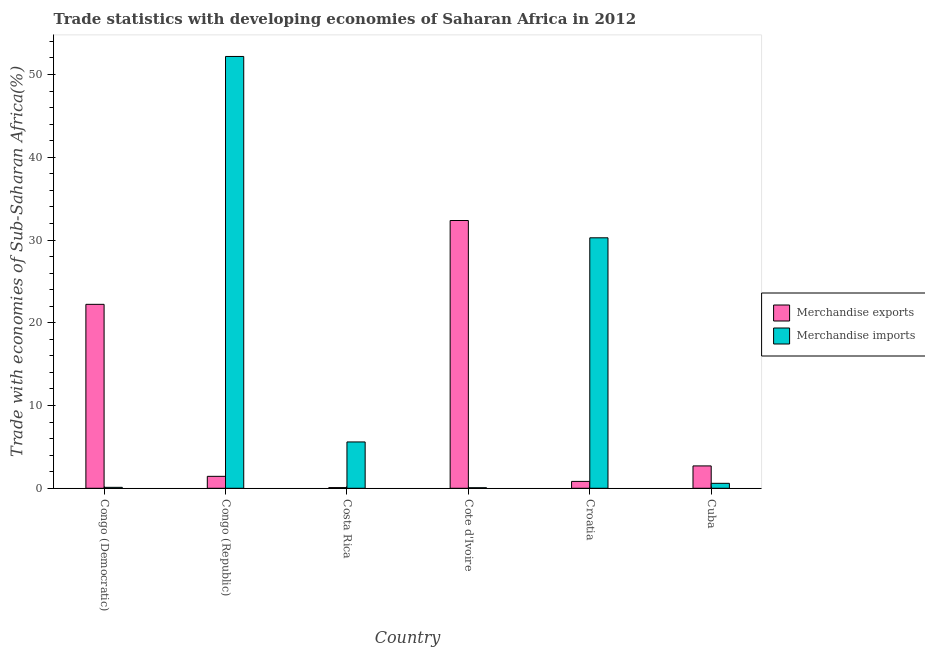How many different coloured bars are there?
Offer a very short reply. 2. How many groups of bars are there?
Keep it short and to the point. 6. How many bars are there on the 5th tick from the right?
Give a very brief answer. 2. What is the label of the 2nd group of bars from the left?
Your response must be concise. Congo (Republic). What is the merchandise imports in Congo (Republic)?
Your answer should be very brief. 52.18. Across all countries, what is the maximum merchandise exports?
Keep it short and to the point. 32.36. Across all countries, what is the minimum merchandise imports?
Give a very brief answer. 0.07. In which country was the merchandise exports maximum?
Your answer should be very brief. Cote d'Ivoire. In which country was the merchandise imports minimum?
Your response must be concise. Cote d'Ivoire. What is the total merchandise imports in the graph?
Provide a short and direct response. 88.83. What is the difference between the merchandise imports in Congo (Republic) and that in Croatia?
Your answer should be very brief. 21.92. What is the difference between the merchandise exports in Congo (Republic) and the merchandise imports in Croatia?
Your answer should be very brief. -28.83. What is the average merchandise exports per country?
Offer a terse response. 9.94. What is the difference between the merchandise exports and merchandise imports in Cote d'Ivoire?
Offer a very short reply. 32.29. In how many countries, is the merchandise imports greater than 6 %?
Offer a terse response. 2. What is the ratio of the merchandise imports in Congo (Democratic) to that in Croatia?
Your answer should be very brief. 0. Is the merchandise imports in Congo (Republic) less than that in Cuba?
Your answer should be compact. No. What is the difference between the highest and the second highest merchandise imports?
Give a very brief answer. 21.92. What is the difference between the highest and the lowest merchandise imports?
Your response must be concise. 52.12. In how many countries, is the merchandise exports greater than the average merchandise exports taken over all countries?
Provide a succinct answer. 2. Is the sum of the merchandise exports in Congo (Republic) and Cuba greater than the maximum merchandise imports across all countries?
Provide a short and direct response. No. What does the 1st bar from the left in Congo (Democratic) represents?
Keep it short and to the point. Merchandise exports. How many bars are there?
Provide a succinct answer. 12. What is the difference between two consecutive major ticks on the Y-axis?
Keep it short and to the point. 10. Does the graph contain grids?
Keep it short and to the point. No. How many legend labels are there?
Ensure brevity in your answer.  2. How are the legend labels stacked?
Offer a terse response. Vertical. What is the title of the graph?
Your answer should be very brief. Trade statistics with developing economies of Saharan Africa in 2012. What is the label or title of the Y-axis?
Provide a short and direct response. Trade with economies of Sub-Saharan Africa(%). What is the Trade with economies of Sub-Saharan Africa(%) in Merchandise exports in Congo (Democratic)?
Give a very brief answer. 22.23. What is the Trade with economies of Sub-Saharan Africa(%) in Merchandise imports in Congo (Democratic)?
Make the answer very short. 0.11. What is the Trade with economies of Sub-Saharan Africa(%) of Merchandise exports in Congo (Republic)?
Keep it short and to the point. 1.44. What is the Trade with economies of Sub-Saharan Africa(%) in Merchandise imports in Congo (Republic)?
Offer a terse response. 52.18. What is the Trade with economies of Sub-Saharan Africa(%) of Merchandise exports in Costa Rica?
Your answer should be compact. 0.08. What is the Trade with economies of Sub-Saharan Africa(%) of Merchandise imports in Costa Rica?
Provide a succinct answer. 5.6. What is the Trade with economies of Sub-Saharan Africa(%) of Merchandise exports in Cote d'Ivoire?
Make the answer very short. 32.36. What is the Trade with economies of Sub-Saharan Africa(%) in Merchandise imports in Cote d'Ivoire?
Make the answer very short. 0.07. What is the Trade with economies of Sub-Saharan Africa(%) of Merchandise exports in Croatia?
Your answer should be compact. 0.83. What is the Trade with economies of Sub-Saharan Africa(%) of Merchandise imports in Croatia?
Provide a succinct answer. 30.27. What is the Trade with economies of Sub-Saharan Africa(%) of Merchandise exports in Cuba?
Give a very brief answer. 2.7. What is the Trade with economies of Sub-Saharan Africa(%) of Merchandise imports in Cuba?
Make the answer very short. 0.6. Across all countries, what is the maximum Trade with economies of Sub-Saharan Africa(%) of Merchandise exports?
Keep it short and to the point. 32.36. Across all countries, what is the maximum Trade with economies of Sub-Saharan Africa(%) in Merchandise imports?
Make the answer very short. 52.18. Across all countries, what is the minimum Trade with economies of Sub-Saharan Africa(%) of Merchandise exports?
Your response must be concise. 0.08. Across all countries, what is the minimum Trade with economies of Sub-Saharan Africa(%) in Merchandise imports?
Your response must be concise. 0.07. What is the total Trade with economies of Sub-Saharan Africa(%) in Merchandise exports in the graph?
Make the answer very short. 59.65. What is the total Trade with economies of Sub-Saharan Africa(%) in Merchandise imports in the graph?
Provide a succinct answer. 88.83. What is the difference between the Trade with economies of Sub-Saharan Africa(%) in Merchandise exports in Congo (Democratic) and that in Congo (Republic)?
Your answer should be compact. 20.79. What is the difference between the Trade with economies of Sub-Saharan Africa(%) of Merchandise imports in Congo (Democratic) and that in Congo (Republic)?
Make the answer very short. -52.07. What is the difference between the Trade with economies of Sub-Saharan Africa(%) of Merchandise exports in Congo (Democratic) and that in Costa Rica?
Keep it short and to the point. 22.15. What is the difference between the Trade with economies of Sub-Saharan Africa(%) in Merchandise imports in Congo (Democratic) and that in Costa Rica?
Provide a succinct answer. -5.48. What is the difference between the Trade with economies of Sub-Saharan Africa(%) in Merchandise exports in Congo (Democratic) and that in Cote d'Ivoire?
Give a very brief answer. -10.13. What is the difference between the Trade with economies of Sub-Saharan Africa(%) of Merchandise imports in Congo (Democratic) and that in Cote d'Ivoire?
Your answer should be compact. 0.05. What is the difference between the Trade with economies of Sub-Saharan Africa(%) in Merchandise exports in Congo (Democratic) and that in Croatia?
Give a very brief answer. 21.4. What is the difference between the Trade with economies of Sub-Saharan Africa(%) in Merchandise imports in Congo (Democratic) and that in Croatia?
Your answer should be very brief. -30.15. What is the difference between the Trade with economies of Sub-Saharan Africa(%) of Merchandise exports in Congo (Democratic) and that in Cuba?
Your answer should be very brief. 19.53. What is the difference between the Trade with economies of Sub-Saharan Africa(%) of Merchandise imports in Congo (Democratic) and that in Cuba?
Ensure brevity in your answer.  -0.49. What is the difference between the Trade with economies of Sub-Saharan Africa(%) of Merchandise exports in Congo (Republic) and that in Costa Rica?
Provide a succinct answer. 1.36. What is the difference between the Trade with economies of Sub-Saharan Africa(%) in Merchandise imports in Congo (Republic) and that in Costa Rica?
Give a very brief answer. 46.59. What is the difference between the Trade with economies of Sub-Saharan Africa(%) of Merchandise exports in Congo (Republic) and that in Cote d'Ivoire?
Ensure brevity in your answer.  -30.92. What is the difference between the Trade with economies of Sub-Saharan Africa(%) in Merchandise imports in Congo (Republic) and that in Cote d'Ivoire?
Offer a very short reply. 52.12. What is the difference between the Trade with economies of Sub-Saharan Africa(%) of Merchandise exports in Congo (Republic) and that in Croatia?
Provide a succinct answer. 0.61. What is the difference between the Trade with economies of Sub-Saharan Africa(%) of Merchandise imports in Congo (Republic) and that in Croatia?
Provide a succinct answer. 21.92. What is the difference between the Trade with economies of Sub-Saharan Africa(%) in Merchandise exports in Congo (Republic) and that in Cuba?
Provide a succinct answer. -1.26. What is the difference between the Trade with economies of Sub-Saharan Africa(%) in Merchandise imports in Congo (Republic) and that in Cuba?
Make the answer very short. 51.58. What is the difference between the Trade with economies of Sub-Saharan Africa(%) of Merchandise exports in Costa Rica and that in Cote d'Ivoire?
Your answer should be very brief. -32.28. What is the difference between the Trade with economies of Sub-Saharan Africa(%) of Merchandise imports in Costa Rica and that in Cote d'Ivoire?
Make the answer very short. 5.53. What is the difference between the Trade with economies of Sub-Saharan Africa(%) of Merchandise exports in Costa Rica and that in Croatia?
Your answer should be very brief. -0.75. What is the difference between the Trade with economies of Sub-Saharan Africa(%) of Merchandise imports in Costa Rica and that in Croatia?
Give a very brief answer. -24.67. What is the difference between the Trade with economies of Sub-Saharan Africa(%) of Merchandise exports in Costa Rica and that in Cuba?
Your answer should be very brief. -2.62. What is the difference between the Trade with economies of Sub-Saharan Africa(%) in Merchandise imports in Costa Rica and that in Cuba?
Offer a very short reply. 5. What is the difference between the Trade with economies of Sub-Saharan Africa(%) of Merchandise exports in Cote d'Ivoire and that in Croatia?
Keep it short and to the point. 31.53. What is the difference between the Trade with economies of Sub-Saharan Africa(%) in Merchandise imports in Cote d'Ivoire and that in Croatia?
Provide a succinct answer. -30.2. What is the difference between the Trade with economies of Sub-Saharan Africa(%) in Merchandise exports in Cote d'Ivoire and that in Cuba?
Keep it short and to the point. 29.66. What is the difference between the Trade with economies of Sub-Saharan Africa(%) in Merchandise imports in Cote d'Ivoire and that in Cuba?
Your answer should be compact. -0.53. What is the difference between the Trade with economies of Sub-Saharan Africa(%) of Merchandise exports in Croatia and that in Cuba?
Give a very brief answer. -1.87. What is the difference between the Trade with economies of Sub-Saharan Africa(%) in Merchandise imports in Croatia and that in Cuba?
Your answer should be very brief. 29.67. What is the difference between the Trade with economies of Sub-Saharan Africa(%) in Merchandise exports in Congo (Democratic) and the Trade with economies of Sub-Saharan Africa(%) in Merchandise imports in Congo (Republic)?
Offer a very short reply. -29.96. What is the difference between the Trade with economies of Sub-Saharan Africa(%) in Merchandise exports in Congo (Democratic) and the Trade with economies of Sub-Saharan Africa(%) in Merchandise imports in Costa Rica?
Make the answer very short. 16.63. What is the difference between the Trade with economies of Sub-Saharan Africa(%) of Merchandise exports in Congo (Democratic) and the Trade with economies of Sub-Saharan Africa(%) of Merchandise imports in Cote d'Ivoire?
Provide a short and direct response. 22.16. What is the difference between the Trade with economies of Sub-Saharan Africa(%) in Merchandise exports in Congo (Democratic) and the Trade with economies of Sub-Saharan Africa(%) in Merchandise imports in Croatia?
Provide a short and direct response. -8.04. What is the difference between the Trade with economies of Sub-Saharan Africa(%) in Merchandise exports in Congo (Democratic) and the Trade with economies of Sub-Saharan Africa(%) in Merchandise imports in Cuba?
Offer a very short reply. 21.63. What is the difference between the Trade with economies of Sub-Saharan Africa(%) of Merchandise exports in Congo (Republic) and the Trade with economies of Sub-Saharan Africa(%) of Merchandise imports in Costa Rica?
Your answer should be compact. -4.16. What is the difference between the Trade with economies of Sub-Saharan Africa(%) in Merchandise exports in Congo (Republic) and the Trade with economies of Sub-Saharan Africa(%) in Merchandise imports in Cote d'Ivoire?
Provide a short and direct response. 1.38. What is the difference between the Trade with economies of Sub-Saharan Africa(%) of Merchandise exports in Congo (Republic) and the Trade with economies of Sub-Saharan Africa(%) of Merchandise imports in Croatia?
Your answer should be compact. -28.83. What is the difference between the Trade with economies of Sub-Saharan Africa(%) of Merchandise exports in Congo (Republic) and the Trade with economies of Sub-Saharan Africa(%) of Merchandise imports in Cuba?
Give a very brief answer. 0.84. What is the difference between the Trade with economies of Sub-Saharan Africa(%) of Merchandise exports in Costa Rica and the Trade with economies of Sub-Saharan Africa(%) of Merchandise imports in Cote d'Ivoire?
Ensure brevity in your answer.  0.01. What is the difference between the Trade with economies of Sub-Saharan Africa(%) of Merchandise exports in Costa Rica and the Trade with economies of Sub-Saharan Africa(%) of Merchandise imports in Croatia?
Provide a short and direct response. -30.19. What is the difference between the Trade with economies of Sub-Saharan Africa(%) in Merchandise exports in Costa Rica and the Trade with economies of Sub-Saharan Africa(%) in Merchandise imports in Cuba?
Provide a succinct answer. -0.52. What is the difference between the Trade with economies of Sub-Saharan Africa(%) in Merchandise exports in Cote d'Ivoire and the Trade with economies of Sub-Saharan Africa(%) in Merchandise imports in Croatia?
Your answer should be very brief. 2.09. What is the difference between the Trade with economies of Sub-Saharan Africa(%) of Merchandise exports in Cote d'Ivoire and the Trade with economies of Sub-Saharan Africa(%) of Merchandise imports in Cuba?
Give a very brief answer. 31.76. What is the difference between the Trade with economies of Sub-Saharan Africa(%) in Merchandise exports in Croatia and the Trade with economies of Sub-Saharan Africa(%) in Merchandise imports in Cuba?
Your response must be concise. 0.23. What is the average Trade with economies of Sub-Saharan Africa(%) of Merchandise exports per country?
Your answer should be very brief. 9.94. What is the average Trade with economies of Sub-Saharan Africa(%) of Merchandise imports per country?
Your answer should be very brief. 14.81. What is the difference between the Trade with economies of Sub-Saharan Africa(%) of Merchandise exports and Trade with economies of Sub-Saharan Africa(%) of Merchandise imports in Congo (Democratic)?
Your answer should be very brief. 22.11. What is the difference between the Trade with economies of Sub-Saharan Africa(%) of Merchandise exports and Trade with economies of Sub-Saharan Africa(%) of Merchandise imports in Congo (Republic)?
Provide a succinct answer. -50.74. What is the difference between the Trade with economies of Sub-Saharan Africa(%) of Merchandise exports and Trade with economies of Sub-Saharan Africa(%) of Merchandise imports in Costa Rica?
Make the answer very short. -5.52. What is the difference between the Trade with economies of Sub-Saharan Africa(%) in Merchandise exports and Trade with economies of Sub-Saharan Africa(%) in Merchandise imports in Cote d'Ivoire?
Make the answer very short. 32.29. What is the difference between the Trade with economies of Sub-Saharan Africa(%) of Merchandise exports and Trade with economies of Sub-Saharan Africa(%) of Merchandise imports in Croatia?
Provide a short and direct response. -29.44. What is the difference between the Trade with economies of Sub-Saharan Africa(%) of Merchandise exports and Trade with economies of Sub-Saharan Africa(%) of Merchandise imports in Cuba?
Your response must be concise. 2.1. What is the ratio of the Trade with economies of Sub-Saharan Africa(%) in Merchandise exports in Congo (Democratic) to that in Congo (Republic)?
Ensure brevity in your answer.  15.41. What is the ratio of the Trade with economies of Sub-Saharan Africa(%) of Merchandise imports in Congo (Democratic) to that in Congo (Republic)?
Offer a terse response. 0. What is the ratio of the Trade with economies of Sub-Saharan Africa(%) of Merchandise exports in Congo (Democratic) to that in Costa Rica?
Your answer should be very brief. 272.41. What is the ratio of the Trade with economies of Sub-Saharan Africa(%) in Merchandise imports in Congo (Democratic) to that in Costa Rica?
Make the answer very short. 0.02. What is the ratio of the Trade with economies of Sub-Saharan Africa(%) of Merchandise exports in Congo (Democratic) to that in Cote d'Ivoire?
Your answer should be very brief. 0.69. What is the ratio of the Trade with economies of Sub-Saharan Africa(%) of Merchandise imports in Congo (Democratic) to that in Cote d'Ivoire?
Your response must be concise. 1.7. What is the ratio of the Trade with economies of Sub-Saharan Africa(%) in Merchandise exports in Congo (Democratic) to that in Croatia?
Ensure brevity in your answer.  26.71. What is the ratio of the Trade with economies of Sub-Saharan Africa(%) of Merchandise imports in Congo (Democratic) to that in Croatia?
Provide a succinct answer. 0. What is the ratio of the Trade with economies of Sub-Saharan Africa(%) in Merchandise exports in Congo (Democratic) to that in Cuba?
Your answer should be compact. 8.23. What is the ratio of the Trade with economies of Sub-Saharan Africa(%) of Merchandise imports in Congo (Democratic) to that in Cuba?
Your answer should be very brief. 0.19. What is the ratio of the Trade with economies of Sub-Saharan Africa(%) in Merchandise exports in Congo (Republic) to that in Costa Rica?
Your response must be concise. 17.68. What is the ratio of the Trade with economies of Sub-Saharan Africa(%) in Merchandise imports in Congo (Republic) to that in Costa Rica?
Keep it short and to the point. 9.32. What is the ratio of the Trade with economies of Sub-Saharan Africa(%) of Merchandise exports in Congo (Republic) to that in Cote d'Ivoire?
Offer a very short reply. 0.04. What is the ratio of the Trade with economies of Sub-Saharan Africa(%) in Merchandise imports in Congo (Republic) to that in Cote d'Ivoire?
Ensure brevity in your answer.  774.17. What is the ratio of the Trade with economies of Sub-Saharan Africa(%) of Merchandise exports in Congo (Republic) to that in Croatia?
Offer a very short reply. 1.73. What is the ratio of the Trade with economies of Sub-Saharan Africa(%) of Merchandise imports in Congo (Republic) to that in Croatia?
Make the answer very short. 1.72. What is the ratio of the Trade with economies of Sub-Saharan Africa(%) in Merchandise exports in Congo (Republic) to that in Cuba?
Keep it short and to the point. 0.53. What is the ratio of the Trade with economies of Sub-Saharan Africa(%) in Merchandise imports in Congo (Republic) to that in Cuba?
Give a very brief answer. 86.96. What is the ratio of the Trade with economies of Sub-Saharan Africa(%) of Merchandise exports in Costa Rica to that in Cote d'Ivoire?
Make the answer very short. 0. What is the ratio of the Trade with economies of Sub-Saharan Africa(%) of Merchandise imports in Costa Rica to that in Cote d'Ivoire?
Offer a very short reply. 83.06. What is the ratio of the Trade with economies of Sub-Saharan Africa(%) of Merchandise exports in Costa Rica to that in Croatia?
Keep it short and to the point. 0.1. What is the ratio of the Trade with economies of Sub-Saharan Africa(%) of Merchandise imports in Costa Rica to that in Croatia?
Ensure brevity in your answer.  0.18. What is the ratio of the Trade with economies of Sub-Saharan Africa(%) in Merchandise exports in Costa Rica to that in Cuba?
Provide a short and direct response. 0.03. What is the ratio of the Trade with economies of Sub-Saharan Africa(%) of Merchandise imports in Costa Rica to that in Cuba?
Give a very brief answer. 9.33. What is the ratio of the Trade with economies of Sub-Saharan Africa(%) in Merchandise exports in Cote d'Ivoire to that in Croatia?
Your answer should be very brief. 38.89. What is the ratio of the Trade with economies of Sub-Saharan Africa(%) in Merchandise imports in Cote d'Ivoire to that in Croatia?
Keep it short and to the point. 0. What is the ratio of the Trade with economies of Sub-Saharan Africa(%) in Merchandise exports in Cote d'Ivoire to that in Cuba?
Keep it short and to the point. 11.98. What is the ratio of the Trade with economies of Sub-Saharan Africa(%) in Merchandise imports in Cote d'Ivoire to that in Cuba?
Ensure brevity in your answer.  0.11. What is the ratio of the Trade with economies of Sub-Saharan Africa(%) of Merchandise exports in Croatia to that in Cuba?
Keep it short and to the point. 0.31. What is the ratio of the Trade with economies of Sub-Saharan Africa(%) of Merchandise imports in Croatia to that in Cuba?
Offer a terse response. 50.44. What is the difference between the highest and the second highest Trade with economies of Sub-Saharan Africa(%) in Merchandise exports?
Your response must be concise. 10.13. What is the difference between the highest and the second highest Trade with economies of Sub-Saharan Africa(%) in Merchandise imports?
Provide a short and direct response. 21.92. What is the difference between the highest and the lowest Trade with economies of Sub-Saharan Africa(%) of Merchandise exports?
Your answer should be very brief. 32.28. What is the difference between the highest and the lowest Trade with economies of Sub-Saharan Africa(%) of Merchandise imports?
Offer a very short reply. 52.12. 